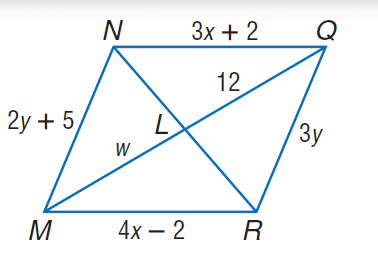Answer the mathemtical geometry problem and directly provide the correct option letter.
Question: Use parallelogram N Q R M to find Q R.
Choices: A: 13 B: 14 C: 15 D: 16 C 